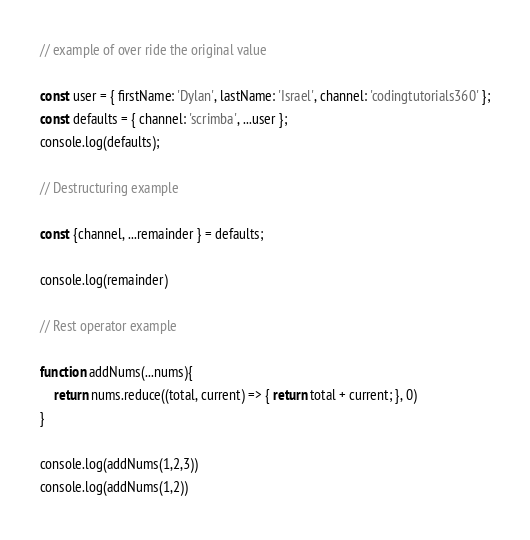Convert code to text. <code><loc_0><loc_0><loc_500><loc_500><_JavaScript_>
// example of over ride the original value

const user = { firstName: 'Dylan', lastName: 'Israel', channel: 'codingtutorials360' };
const defaults = { channel: 'scrimba', ...user };
console.log(defaults);

// Destructuring example

const {channel, ...remainder } = defaults;

console.log(remainder)

// Rest operator example

function addNums(...nums){
    return nums.reduce((total, current) => { return total + current; }, 0)
}

console.log(addNums(1,2,3))
console.log(addNums(1,2))</code> 